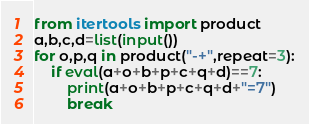<code> <loc_0><loc_0><loc_500><loc_500><_Python_>from itertools import product
a,b,c,d=list(input())
for o,p,q in product("-+",repeat=3):
    if eval(a+o+b+p+c+q+d)==7:
        print(a+o+b+p+c+q+d+"=7")
        break</code> 